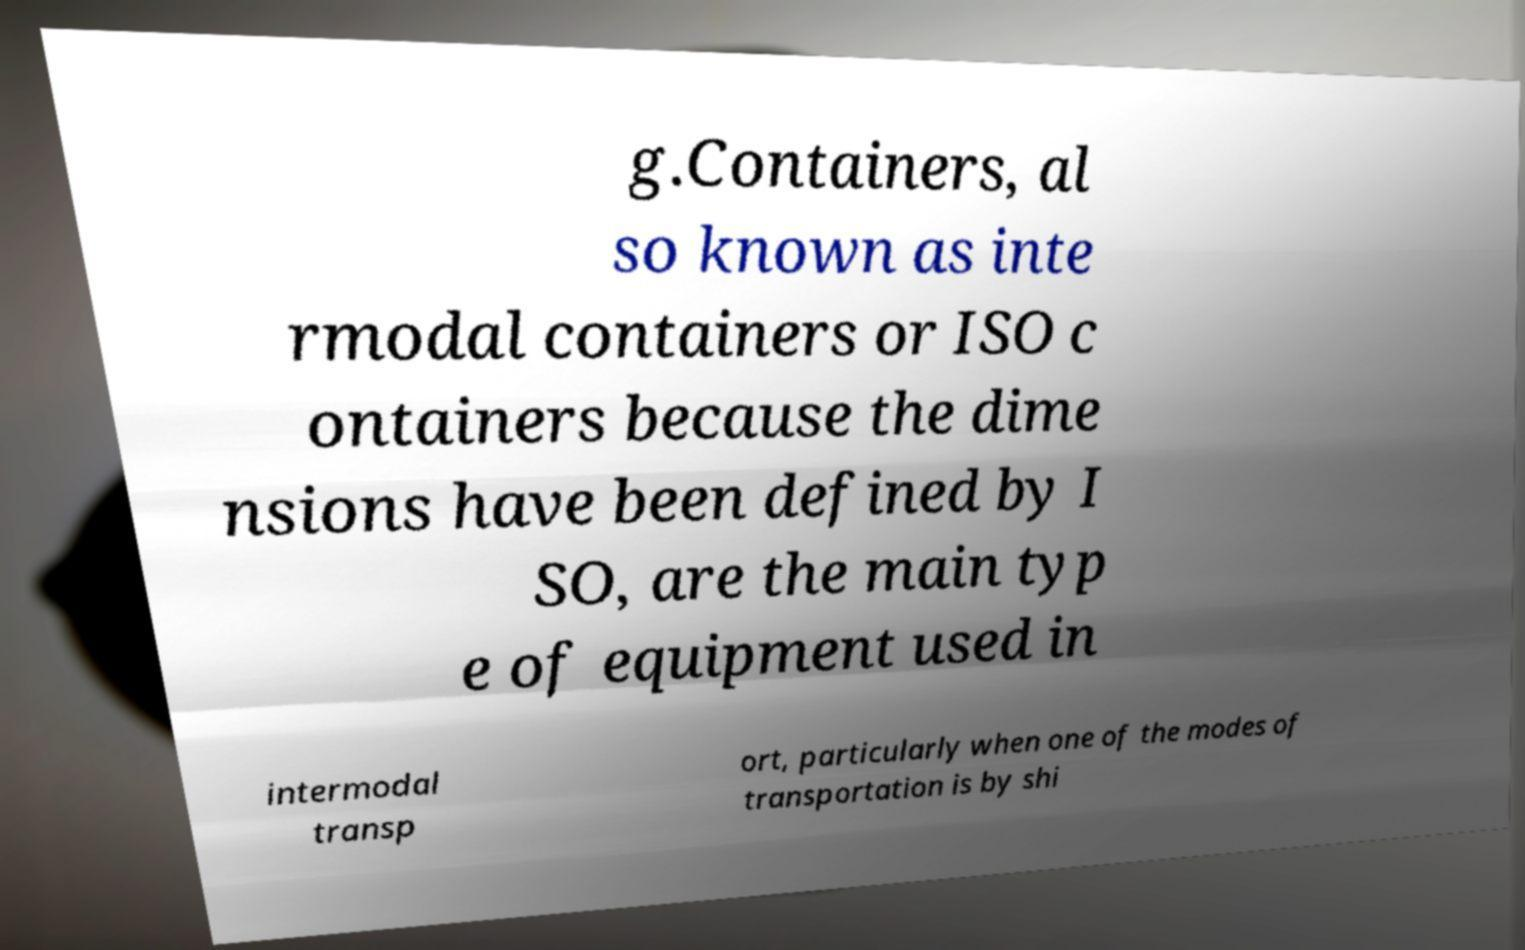Could you extract and type out the text from this image? g.Containers, al so known as inte rmodal containers or ISO c ontainers because the dime nsions have been defined by I SO, are the main typ e of equipment used in intermodal transp ort, particularly when one of the modes of transportation is by shi 